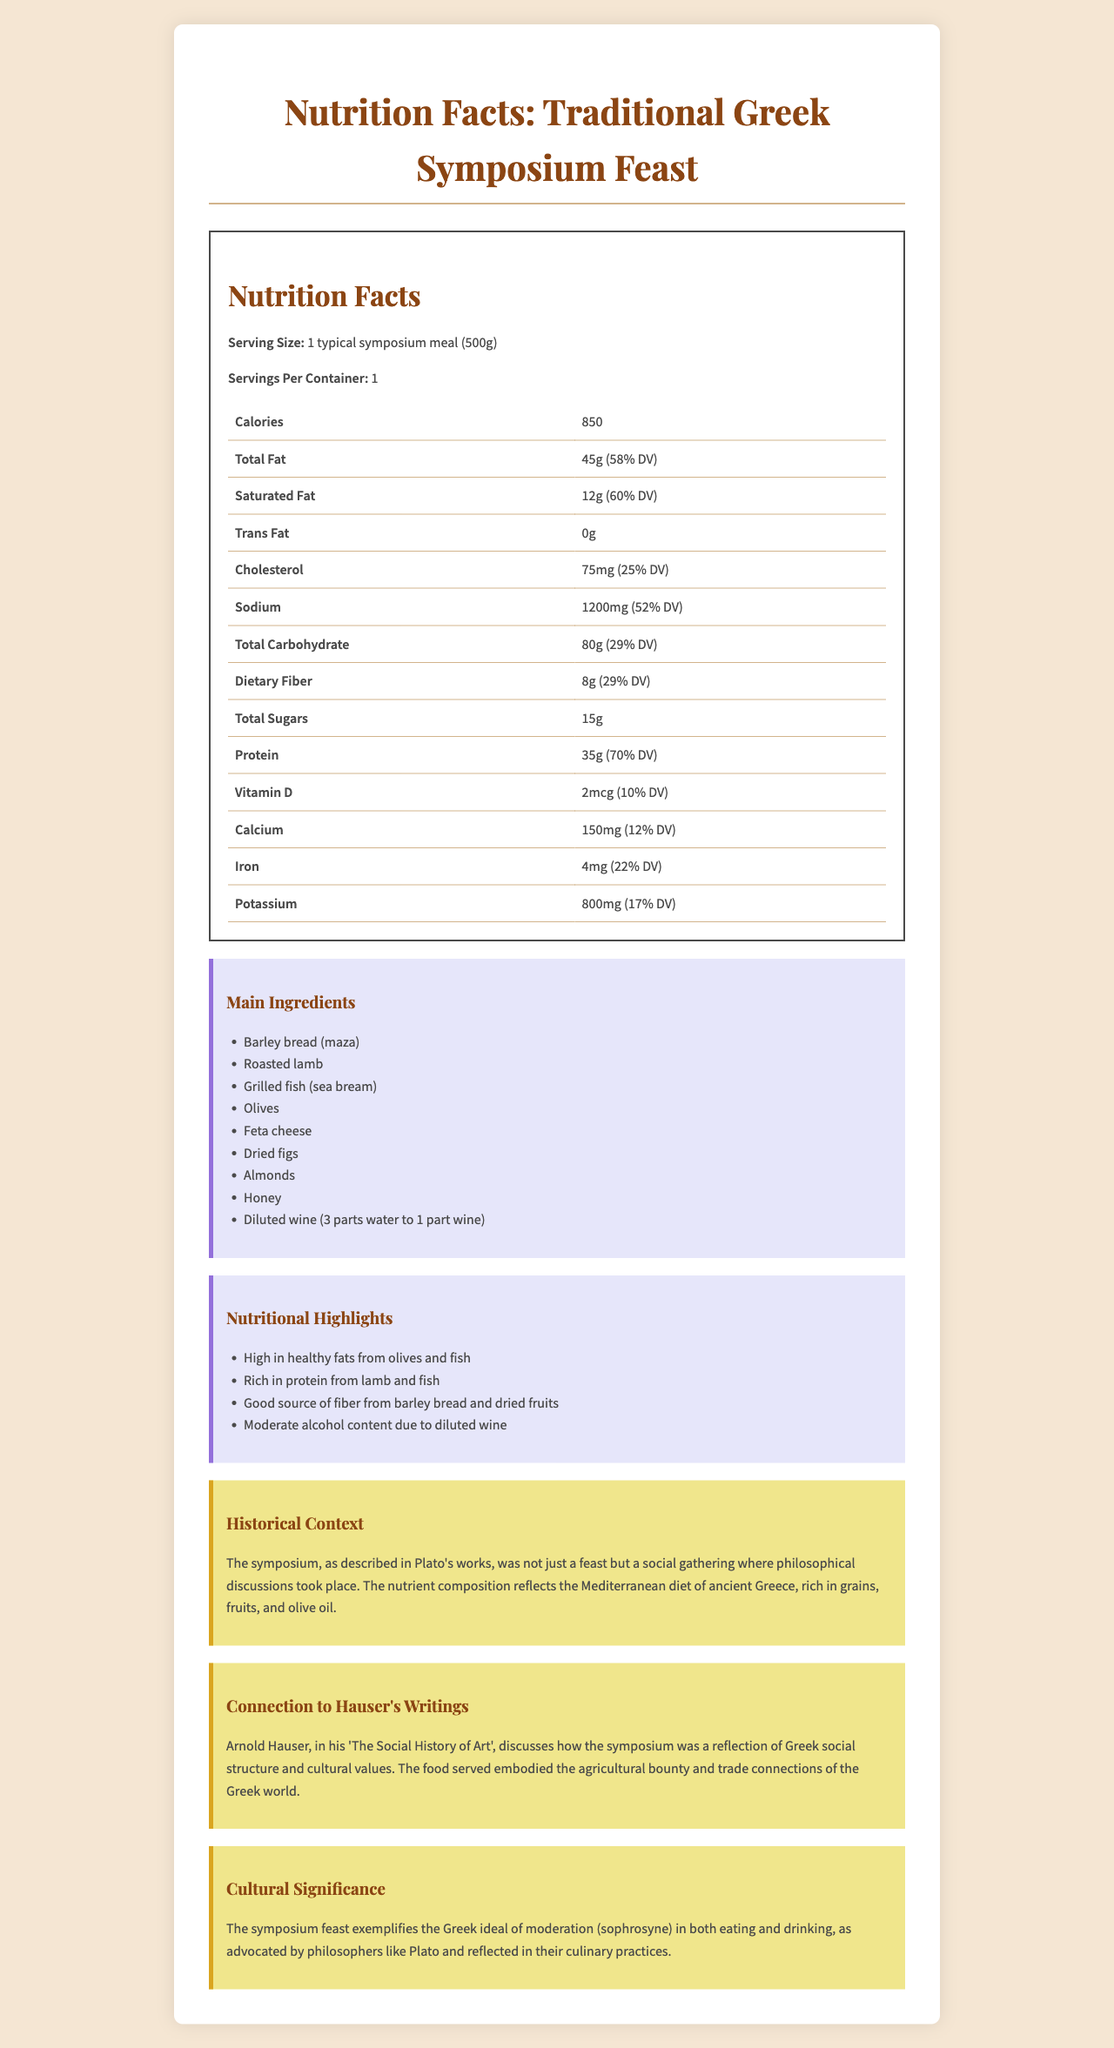what is the serving size mentioned? The serving size is explicitly listed as "1 typical symposium meal (500g)" under the Nutrition Facts section.
Answer: 1 typical symposium meal (500g) how many grams of total fat are in the meal? The document shows that the total fat in the meal is 45 grams.
Answer: 45g what is the percentage of daily value for saturated fat? The daily value percentage for saturated fat listed in the document is 60%.
Answer: 60% how much protein is included in the meal? According to the Nutrition Facts, there are 35 grams of protein in the meal.
Answer: 35g which main ingredient provides a good source of fiber? The document mentions that barley bread (maza) and dried fruits are good sources of fiber under the nutritional highlights.
Answer: Barley bread (maza) how many milligrams of sodium are in the meal? The sodium content is listed as 1200 milligrams in the document.
Answer: 1200mg what is the historical context of the symposium feast? The historical context is provided in a detailed paragraph under the Historical Context section.
Answer: The symposium, as described in Plato's works, was not just a feast but a social gathering where philosophical discussions took place. The nutrient composition reflects the Mediterranean diet of ancient Greece, rich in grains, fruits, and olive oil. what is the percentage daily value for iron? The percentage daily value for iron is 22%, as shown in the Nutrition Facts.
Answer: 22% what are some of the main ingredients mentioned? The ingredients are listed in the Main Ingredients section.
Answer: Barley bread (maza), Roasted lamb, Grilled fish (sea bream), Olives, Feta cheese, Dried figs, Almonds, Honey, Diluted wine A symposium is a combination of what two activities? A. Eating and Drinking B. Philosophical Discussions and Drinking C. Eating and Philosophical Discussions D. Exercising and Drinking The historical context mentions that the symposium was a combination of "a feast" and "philosophical discussions."
Answer: C which nutrient has the highest daily value percentage? A. Saturated fat B. Protein C. Sodium D. Fiber Protein has a daily value percentage of 70%, which is the highest among the options provided.
Answer: B is the sugar content in the meal high or low? The total sugars content is 15g, which is relatively low compared to other elements like carbohydrates and fat.
Answer: Low does the historical context mention the agricultural bounty of the Greek world? The description under the Hauser Connection mentions the agricultural bounty of the Greek world.
Answer: Yes how does this meal reflect the cultural values of ancient Greece? The Cultural Significance section explains that the feast reflects the Greek value of moderation.
Answer: The symposium feast exemplifies the Greek ideal of moderation (sophrosyne) in both eating and drinking, as advocated by philosophers like Plato and reflected in their culinary practices. summarize the entire document in a few sentences. The document is well-organized with sections on Nutrition Facts, Main Ingredients, Nutritional Highlights, Historical Context, Hauser's Writings, and Cultural Significance that describe the nutritional, historical, and cultural aspects of a Greek symposium feast.
Answer: The document presents the nutritional composition of a traditional Greek symposium feast, detailing serving size, calories, and the amounts of various nutrients. It also includes the main ingredients and nutritional highlights. The historical and cultural contexts are discussed, emphasizing the symposium's role in Greek society and philosophical traditions. Connections to Arnold Hauser's writings are also provided. which culinary practice discussed is not detailed in the document? The document does not provide detailed culinary practices or preparation methods for individual dishes; it only lists the ingredients and nutritional values.
Answer: Preparation methods of individual dishes how does the meal exemplify the Mediterranean diet? The historical context mentions that the nutrient composition reflects the Mediterranean diet of ancient Greece.
Answer: The meal includes grains like barley bread, fruits like dried figs, olive oil, and seafood, which are characteristic of the Mediterranean diet. 